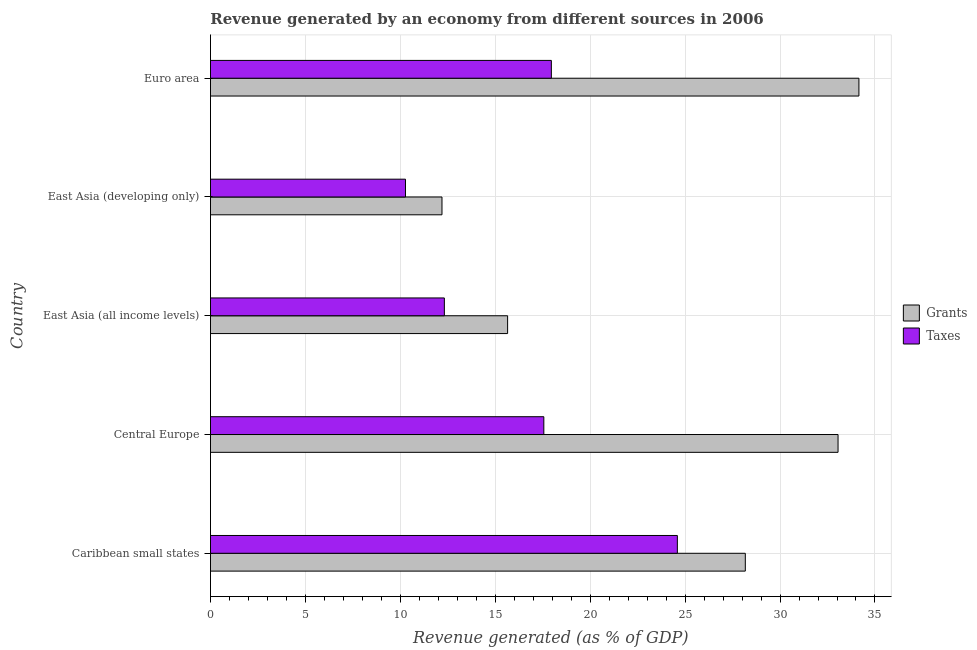How many different coloured bars are there?
Ensure brevity in your answer.  2. How many groups of bars are there?
Give a very brief answer. 5. Are the number of bars on each tick of the Y-axis equal?
Provide a short and direct response. Yes. How many bars are there on the 2nd tick from the bottom?
Give a very brief answer. 2. What is the revenue generated by taxes in Euro area?
Provide a short and direct response. 17.95. Across all countries, what is the maximum revenue generated by taxes?
Your response must be concise. 24.59. Across all countries, what is the minimum revenue generated by taxes?
Offer a terse response. 10.27. In which country was the revenue generated by grants maximum?
Offer a terse response. Euro area. In which country was the revenue generated by grants minimum?
Offer a terse response. East Asia (developing only). What is the total revenue generated by taxes in the graph?
Ensure brevity in your answer.  82.69. What is the difference between the revenue generated by taxes in East Asia (all income levels) and that in Euro area?
Offer a terse response. -5.64. What is the difference between the revenue generated by grants in Euro area and the revenue generated by taxes in East Asia (developing only)?
Offer a very short reply. 23.88. What is the average revenue generated by grants per country?
Ensure brevity in your answer.  24.64. What is the difference between the revenue generated by taxes and revenue generated by grants in East Asia (all income levels)?
Ensure brevity in your answer.  -3.33. What is the ratio of the revenue generated by grants in East Asia (all income levels) to that in Euro area?
Give a very brief answer. 0.46. Is the revenue generated by taxes in Central Europe less than that in Euro area?
Offer a terse response. Yes. Is the difference between the revenue generated by grants in East Asia (developing only) and Euro area greater than the difference between the revenue generated by taxes in East Asia (developing only) and Euro area?
Keep it short and to the point. No. What is the difference between the highest and the lowest revenue generated by taxes?
Your answer should be very brief. 14.32. In how many countries, is the revenue generated by taxes greater than the average revenue generated by taxes taken over all countries?
Make the answer very short. 3. Is the sum of the revenue generated by taxes in Caribbean small states and East Asia (all income levels) greater than the maximum revenue generated by grants across all countries?
Provide a succinct answer. Yes. What does the 1st bar from the top in Central Europe represents?
Ensure brevity in your answer.  Taxes. What does the 2nd bar from the bottom in Euro area represents?
Give a very brief answer. Taxes. How many bars are there?
Give a very brief answer. 10. How many countries are there in the graph?
Your response must be concise. 5. What is the difference between two consecutive major ticks on the X-axis?
Ensure brevity in your answer.  5. Does the graph contain grids?
Keep it short and to the point. Yes. Where does the legend appear in the graph?
Your response must be concise. Center right. How many legend labels are there?
Your response must be concise. 2. How are the legend labels stacked?
Your response must be concise. Vertical. What is the title of the graph?
Your answer should be compact. Revenue generated by an economy from different sources in 2006. What is the label or title of the X-axis?
Keep it short and to the point. Revenue generated (as % of GDP). What is the Revenue generated (as % of GDP) of Grants in Caribbean small states?
Provide a short and direct response. 28.17. What is the Revenue generated (as % of GDP) of Taxes in Caribbean small states?
Keep it short and to the point. 24.59. What is the Revenue generated (as % of GDP) in Grants in Central Europe?
Offer a very short reply. 33.06. What is the Revenue generated (as % of GDP) of Taxes in Central Europe?
Provide a succinct answer. 17.56. What is the Revenue generated (as % of GDP) of Grants in East Asia (all income levels)?
Your response must be concise. 15.65. What is the Revenue generated (as % of GDP) of Taxes in East Asia (all income levels)?
Your response must be concise. 12.32. What is the Revenue generated (as % of GDP) of Grants in East Asia (developing only)?
Provide a succinct answer. 12.19. What is the Revenue generated (as % of GDP) of Taxes in East Asia (developing only)?
Give a very brief answer. 10.27. What is the Revenue generated (as % of GDP) in Grants in Euro area?
Give a very brief answer. 34.15. What is the Revenue generated (as % of GDP) in Taxes in Euro area?
Your answer should be very brief. 17.95. Across all countries, what is the maximum Revenue generated (as % of GDP) in Grants?
Offer a very short reply. 34.15. Across all countries, what is the maximum Revenue generated (as % of GDP) of Taxes?
Provide a succinct answer. 24.59. Across all countries, what is the minimum Revenue generated (as % of GDP) of Grants?
Provide a succinct answer. 12.19. Across all countries, what is the minimum Revenue generated (as % of GDP) in Taxes?
Keep it short and to the point. 10.27. What is the total Revenue generated (as % of GDP) of Grants in the graph?
Offer a very short reply. 123.22. What is the total Revenue generated (as % of GDP) of Taxes in the graph?
Provide a short and direct response. 82.69. What is the difference between the Revenue generated (as % of GDP) in Grants in Caribbean small states and that in Central Europe?
Provide a short and direct response. -4.88. What is the difference between the Revenue generated (as % of GDP) in Taxes in Caribbean small states and that in Central Europe?
Make the answer very short. 7.03. What is the difference between the Revenue generated (as % of GDP) in Grants in Caribbean small states and that in East Asia (all income levels)?
Keep it short and to the point. 12.52. What is the difference between the Revenue generated (as % of GDP) in Taxes in Caribbean small states and that in East Asia (all income levels)?
Your response must be concise. 12.27. What is the difference between the Revenue generated (as % of GDP) in Grants in Caribbean small states and that in East Asia (developing only)?
Your answer should be compact. 15.98. What is the difference between the Revenue generated (as % of GDP) of Taxes in Caribbean small states and that in East Asia (developing only)?
Give a very brief answer. 14.32. What is the difference between the Revenue generated (as % of GDP) in Grants in Caribbean small states and that in Euro area?
Offer a terse response. -5.98. What is the difference between the Revenue generated (as % of GDP) of Taxes in Caribbean small states and that in Euro area?
Your answer should be very brief. 6.64. What is the difference between the Revenue generated (as % of GDP) of Grants in Central Europe and that in East Asia (all income levels)?
Ensure brevity in your answer.  17.4. What is the difference between the Revenue generated (as % of GDP) of Taxes in Central Europe and that in East Asia (all income levels)?
Offer a very short reply. 5.24. What is the difference between the Revenue generated (as % of GDP) in Grants in Central Europe and that in East Asia (developing only)?
Make the answer very short. 20.86. What is the difference between the Revenue generated (as % of GDP) in Taxes in Central Europe and that in East Asia (developing only)?
Make the answer very short. 7.29. What is the difference between the Revenue generated (as % of GDP) of Grants in Central Europe and that in Euro area?
Ensure brevity in your answer.  -1.1. What is the difference between the Revenue generated (as % of GDP) in Taxes in Central Europe and that in Euro area?
Offer a terse response. -0.4. What is the difference between the Revenue generated (as % of GDP) in Grants in East Asia (all income levels) and that in East Asia (developing only)?
Offer a very short reply. 3.46. What is the difference between the Revenue generated (as % of GDP) of Taxes in East Asia (all income levels) and that in East Asia (developing only)?
Ensure brevity in your answer.  2.05. What is the difference between the Revenue generated (as % of GDP) in Grants in East Asia (all income levels) and that in Euro area?
Offer a very short reply. -18.5. What is the difference between the Revenue generated (as % of GDP) of Taxes in East Asia (all income levels) and that in Euro area?
Your answer should be very brief. -5.64. What is the difference between the Revenue generated (as % of GDP) in Grants in East Asia (developing only) and that in Euro area?
Your answer should be very brief. -21.96. What is the difference between the Revenue generated (as % of GDP) in Taxes in East Asia (developing only) and that in Euro area?
Provide a short and direct response. -7.68. What is the difference between the Revenue generated (as % of GDP) in Grants in Caribbean small states and the Revenue generated (as % of GDP) in Taxes in Central Europe?
Ensure brevity in your answer.  10.61. What is the difference between the Revenue generated (as % of GDP) of Grants in Caribbean small states and the Revenue generated (as % of GDP) of Taxes in East Asia (all income levels)?
Your response must be concise. 15.85. What is the difference between the Revenue generated (as % of GDP) in Grants in Caribbean small states and the Revenue generated (as % of GDP) in Taxes in East Asia (developing only)?
Offer a terse response. 17.9. What is the difference between the Revenue generated (as % of GDP) in Grants in Caribbean small states and the Revenue generated (as % of GDP) in Taxes in Euro area?
Your response must be concise. 10.22. What is the difference between the Revenue generated (as % of GDP) in Grants in Central Europe and the Revenue generated (as % of GDP) in Taxes in East Asia (all income levels)?
Keep it short and to the point. 20.74. What is the difference between the Revenue generated (as % of GDP) in Grants in Central Europe and the Revenue generated (as % of GDP) in Taxes in East Asia (developing only)?
Offer a very short reply. 22.78. What is the difference between the Revenue generated (as % of GDP) of Grants in Central Europe and the Revenue generated (as % of GDP) of Taxes in Euro area?
Your answer should be compact. 15.1. What is the difference between the Revenue generated (as % of GDP) of Grants in East Asia (all income levels) and the Revenue generated (as % of GDP) of Taxes in East Asia (developing only)?
Offer a very short reply. 5.38. What is the difference between the Revenue generated (as % of GDP) in Grants in East Asia (all income levels) and the Revenue generated (as % of GDP) in Taxes in Euro area?
Make the answer very short. -2.3. What is the difference between the Revenue generated (as % of GDP) in Grants in East Asia (developing only) and the Revenue generated (as % of GDP) in Taxes in Euro area?
Your answer should be very brief. -5.76. What is the average Revenue generated (as % of GDP) of Grants per country?
Your answer should be compact. 24.64. What is the average Revenue generated (as % of GDP) in Taxes per country?
Give a very brief answer. 16.54. What is the difference between the Revenue generated (as % of GDP) in Grants and Revenue generated (as % of GDP) in Taxes in Caribbean small states?
Offer a very short reply. 3.58. What is the difference between the Revenue generated (as % of GDP) in Grants and Revenue generated (as % of GDP) in Taxes in Central Europe?
Provide a succinct answer. 15.5. What is the difference between the Revenue generated (as % of GDP) of Grants and Revenue generated (as % of GDP) of Taxes in East Asia (all income levels)?
Provide a short and direct response. 3.33. What is the difference between the Revenue generated (as % of GDP) in Grants and Revenue generated (as % of GDP) in Taxes in East Asia (developing only)?
Provide a succinct answer. 1.92. What is the difference between the Revenue generated (as % of GDP) in Grants and Revenue generated (as % of GDP) in Taxes in Euro area?
Keep it short and to the point. 16.2. What is the ratio of the Revenue generated (as % of GDP) of Grants in Caribbean small states to that in Central Europe?
Offer a terse response. 0.85. What is the ratio of the Revenue generated (as % of GDP) of Taxes in Caribbean small states to that in Central Europe?
Provide a succinct answer. 1.4. What is the ratio of the Revenue generated (as % of GDP) in Taxes in Caribbean small states to that in East Asia (all income levels)?
Your answer should be very brief. 2. What is the ratio of the Revenue generated (as % of GDP) of Grants in Caribbean small states to that in East Asia (developing only)?
Your response must be concise. 2.31. What is the ratio of the Revenue generated (as % of GDP) of Taxes in Caribbean small states to that in East Asia (developing only)?
Give a very brief answer. 2.39. What is the ratio of the Revenue generated (as % of GDP) of Grants in Caribbean small states to that in Euro area?
Your answer should be very brief. 0.82. What is the ratio of the Revenue generated (as % of GDP) in Taxes in Caribbean small states to that in Euro area?
Ensure brevity in your answer.  1.37. What is the ratio of the Revenue generated (as % of GDP) in Grants in Central Europe to that in East Asia (all income levels)?
Your answer should be compact. 2.11. What is the ratio of the Revenue generated (as % of GDP) of Taxes in Central Europe to that in East Asia (all income levels)?
Offer a terse response. 1.43. What is the ratio of the Revenue generated (as % of GDP) of Grants in Central Europe to that in East Asia (developing only)?
Give a very brief answer. 2.71. What is the ratio of the Revenue generated (as % of GDP) in Taxes in Central Europe to that in East Asia (developing only)?
Your answer should be very brief. 1.71. What is the ratio of the Revenue generated (as % of GDP) in Grants in Central Europe to that in Euro area?
Provide a succinct answer. 0.97. What is the ratio of the Revenue generated (as % of GDP) in Taxes in Central Europe to that in Euro area?
Your response must be concise. 0.98. What is the ratio of the Revenue generated (as % of GDP) of Grants in East Asia (all income levels) to that in East Asia (developing only)?
Your response must be concise. 1.28. What is the ratio of the Revenue generated (as % of GDP) of Taxes in East Asia (all income levels) to that in East Asia (developing only)?
Your response must be concise. 1.2. What is the ratio of the Revenue generated (as % of GDP) in Grants in East Asia (all income levels) to that in Euro area?
Provide a short and direct response. 0.46. What is the ratio of the Revenue generated (as % of GDP) in Taxes in East Asia (all income levels) to that in Euro area?
Make the answer very short. 0.69. What is the ratio of the Revenue generated (as % of GDP) in Grants in East Asia (developing only) to that in Euro area?
Provide a succinct answer. 0.36. What is the ratio of the Revenue generated (as % of GDP) in Taxes in East Asia (developing only) to that in Euro area?
Make the answer very short. 0.57. What is the difference between the highest and the second highest Revenue generated (as % of GDP) of Grants?
Make the answer very short. 1.1. What is the difference between the highest and the second highest Revenue generated (as % of GDP) of Taxes?
Give a very brief answer. 6.64. What is the difference between the highest and the lowest Revenue generated (as % of GDP) in Grants?
Give a very brief answer. 21.96. What is the difference between the highest and the lowest Revenue generated (as % of GDP) of Taxes?
Make the answer very short. 14.32. 